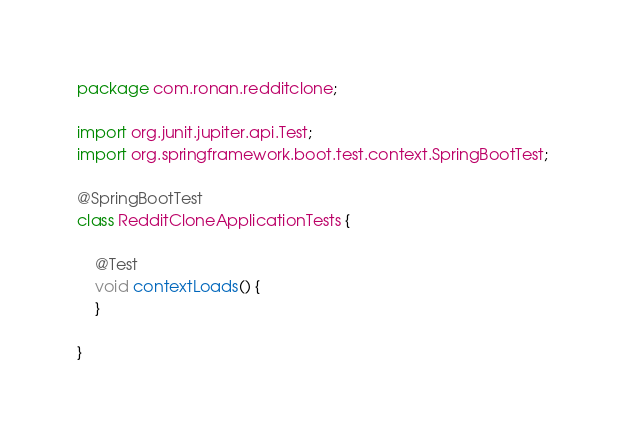Convert code to text. <code><loc_0><loc_0><loc_500><loc_500><_Java_>package com.ronan.redditclone;

import org.junit.jupiter.api.Test;
import org.springframework.boot.test.context.SpringBootTest;

@SpringBootTest
class RedditCloneApplicationTests {

	@Test
	void contextLoads() {
	}

}
</code> 